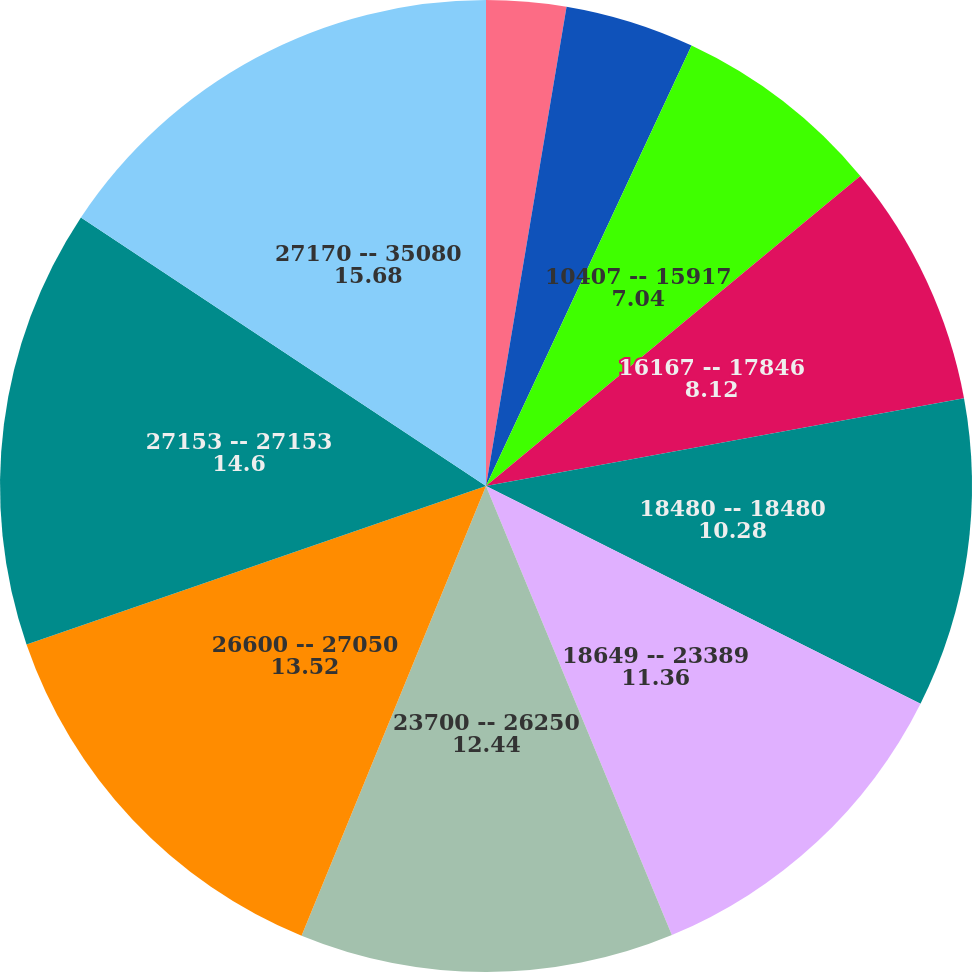Convert chart. <chart><loc_0><loc_0><loc_500><loc_500><pie_chart><fcel>0009 -- 6370<fcel>6525 -- 10037<fcel>10407 -- 15917<fcel>16167 -- 17846<fcel>18480 -- 18480<fcel>18649 -- 23389<fcel>23700 -- 26250<fcel>26600 -- 27050<fcel>27153 -- 27153<fcel>27170 -- 35080<nl><fcel>2.65%<fcel>4.3%<fcel>7.04%<fcel>8.12%<fcel>10.28%<fcel>11.36%<fcel>12.44%<fcel>13.52%<fcel>14.6%<fcel>15.68%<nl></chart> 